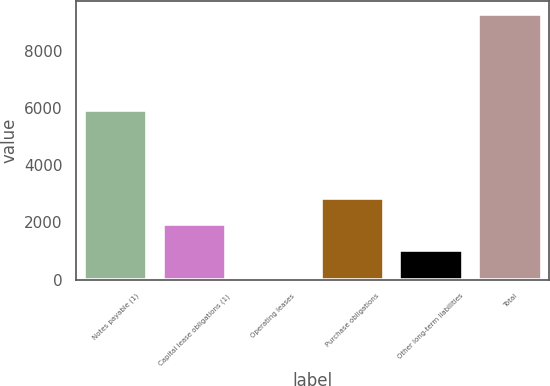Convert chart to OTSL. <chart><loc_0><loc_0><loc_500><loc_500><bar_chart><fcel>Notes payable (1)<fcel>Capital lease obligations (1)<fcel>Operating leases<fcel>Purchase obligations<fcel>Other long-term liabilities<fcel>Total<nl><fcel>5951<fcel>1946.8<fcel>106<fcel>2867.2<fcel>1026.4<fcel>9310<nl></chart> 